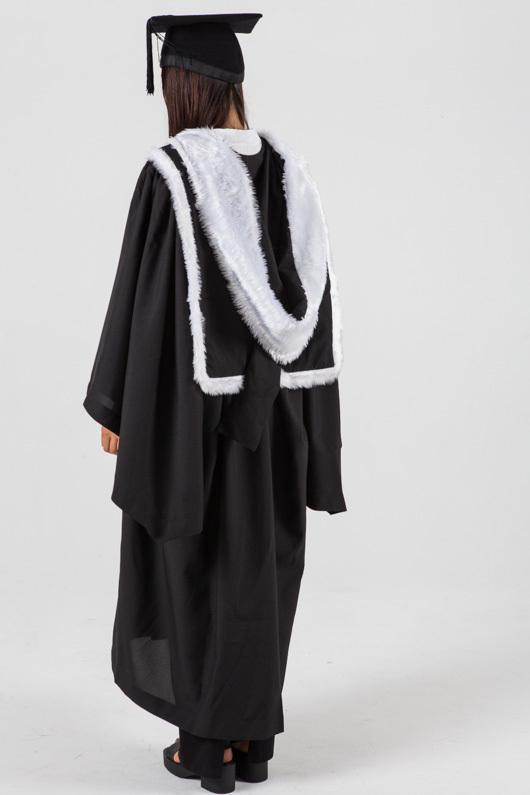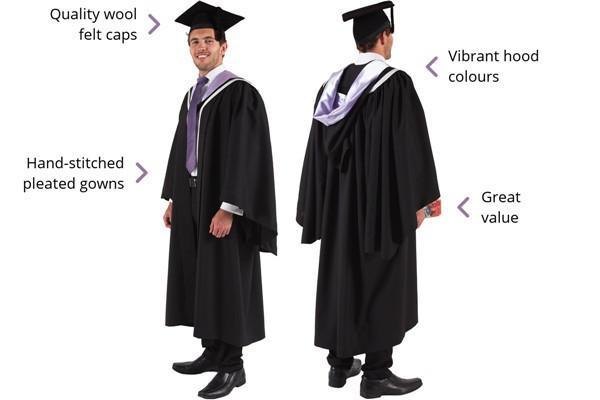The first image is the image on the left, the second image is the image on the right. Examine the images to the left and right. Is the description "There is a woman in the image on the right." accurate? Answer yes or no. No. 